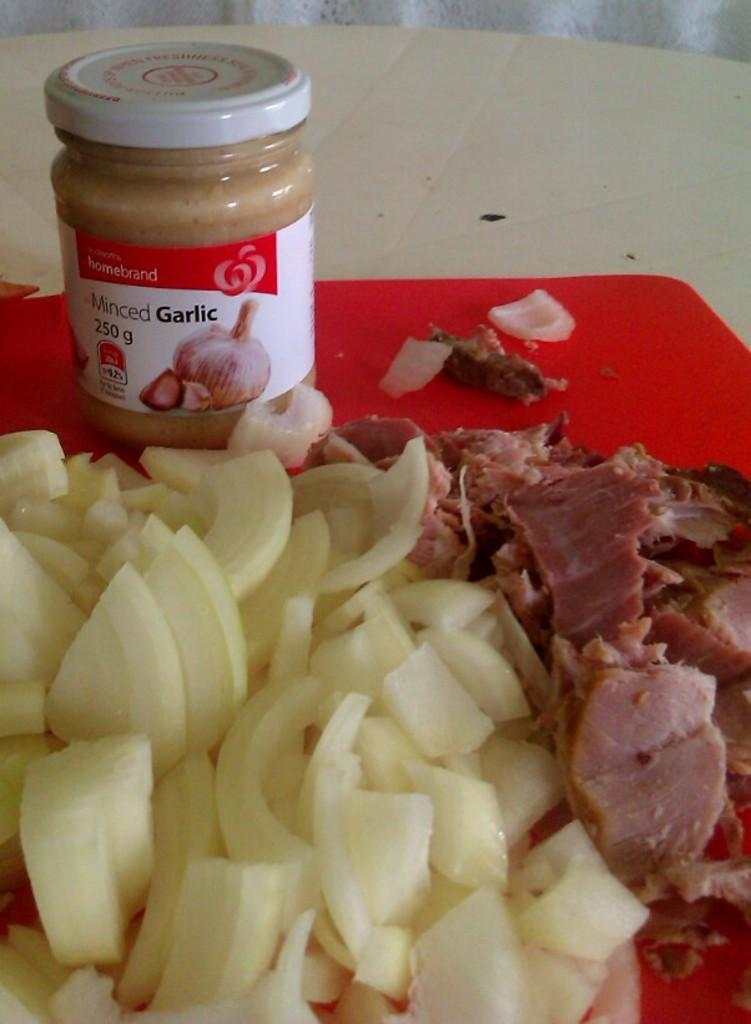What type of food item is shown in the image? There are slices of a food item in the image. What other ingredient is present in the image? There is meat in the image. What condiment can be seen in the plastic container? The plastic container has garlic paste in it. Where is the plastic container located? The plastic container is on a table. What surface is the food placed on? The board is on the table. What type of ice can be seen on the stage in the image? There is no stage or ice present in the image. How does the parent interact with the food in the image? There is no parent present in the image, so it is not possible to determine how they might interact with the food. 